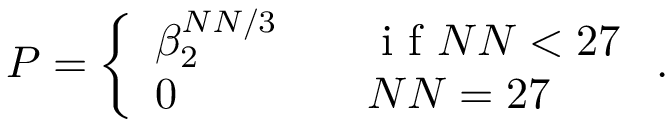<formula> <loc_0><loc_0><loc_500><loc_500>P = \left \{ \begin{array} { l l } { \beta _ { 2 } ^ { N N / 3 } } & { \quad i f N N < 2 7 } \\ { 0 } & { \quad N N = 2 7 } \end{array} .</formula> 